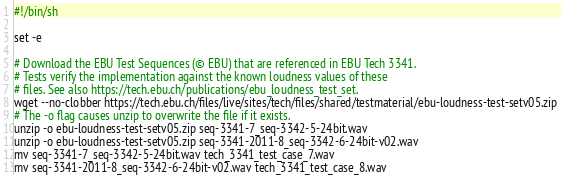<code> <loc_0><loc_0><loc_500><loc_500><_Bash_>#!/bin/sh

set -e

# Download the EBU Test Sequences (© EBU) that are referenced in EBU Tech 3341.
# Tests verify the implementation against the known loudness values of these
# files. See also https://tech.ebu.ch/publications/ebu_loudness_test_set.
wget --no-clobber https://tech.ebu.ch/files/live/sites/tech/files/shared/testmaterial/ebu-loudness-test-setv05.zip
# The -o flag causes unzip to overwrite the file if it exists.
unzip -o ebu-loudness-test-setv05.zip seq-3341-7_seq-3342-5-24bit.wav
unzip -o ebu-loudness-test-setv05.zip seq-3341-2011-8_seq-3342-6-24bit-v02.wav
mv seq-3341-7_seq-3342-5-24bit.wav tech_3341_test_case_7.wav
mv seq-3341-2011-8_seq-3342-6-24bit-v02.wav tech_3341_test_case_8.wav
</code> 